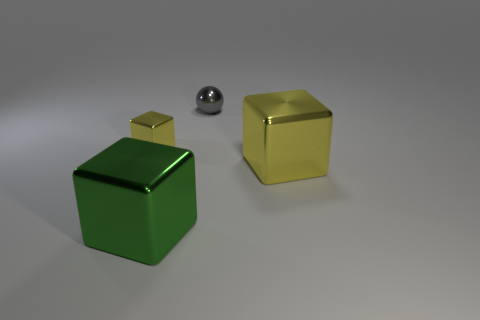Add 4 small matte cubes. How many objects exist? 8 Subtract all blocks. How many objects are left? 1 Add 1 green cubes. How many green cubes are left? 2 Add 4 tiny rubber cubes. How many tiny rubber cubes exist? 4 Subtract 0 blue blocks. How many objects are left? 4 Subtract all shiny things. Subtract all red cylinders. How many objects are left? 0 